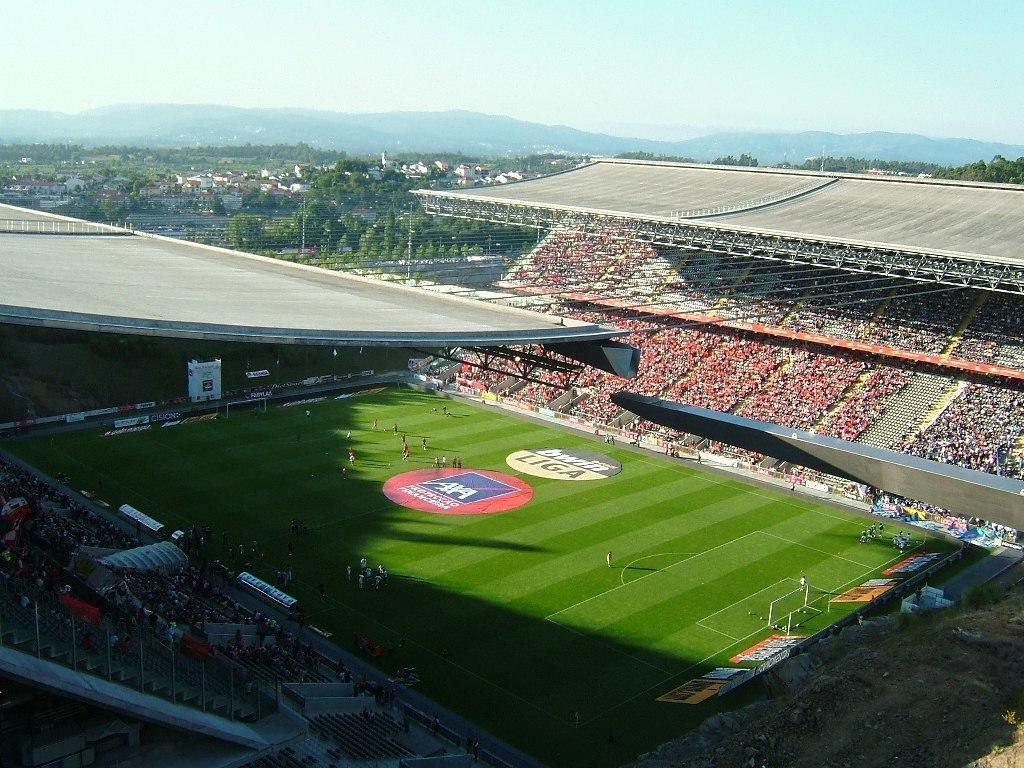What type of location is depicted in the image? The image is of a stadium. Are there any people present in the image? Yes, there are people in the image. What other structures or objects can be seen in the image? There are hoardings, open-sheds, and grass visible in the image. What can be seen in the background of the image? In the background of the image, there are trees, buildings, mountains, and the sky. What type of bells can be heard ringing in the image? There are no bells present in the image, and therefore no sound can be heard. What type of eggnog is being served in the image? There is no eggnog present in the image, and therefore no such beverage can be seen. 